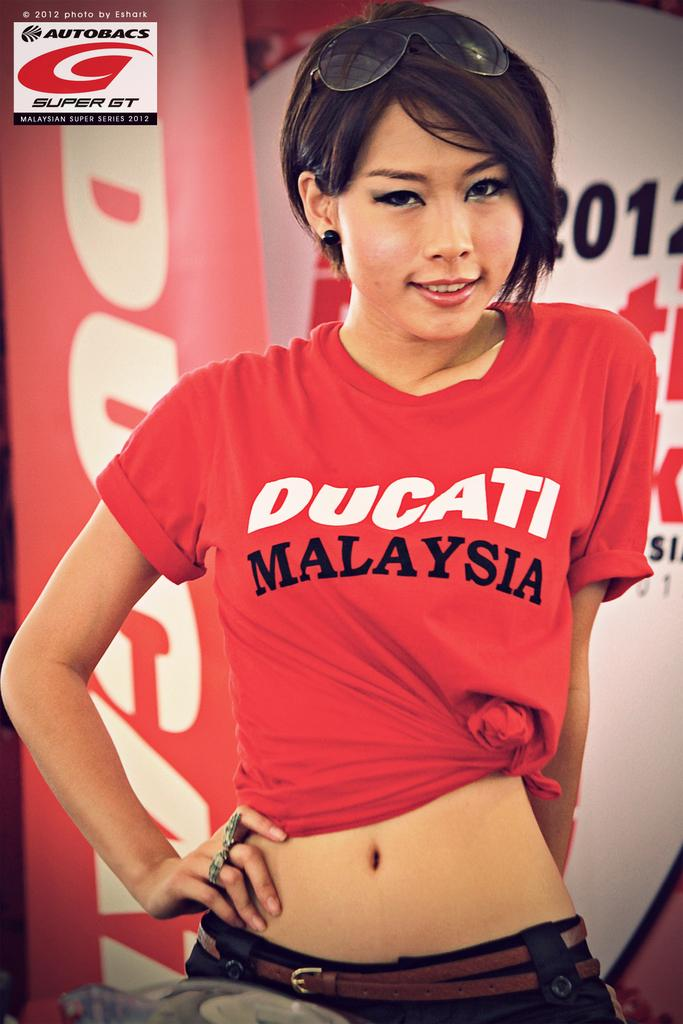Provide a one-sentence caption for the provided image. A model wears a Ducati Malaysia tee shirt. 